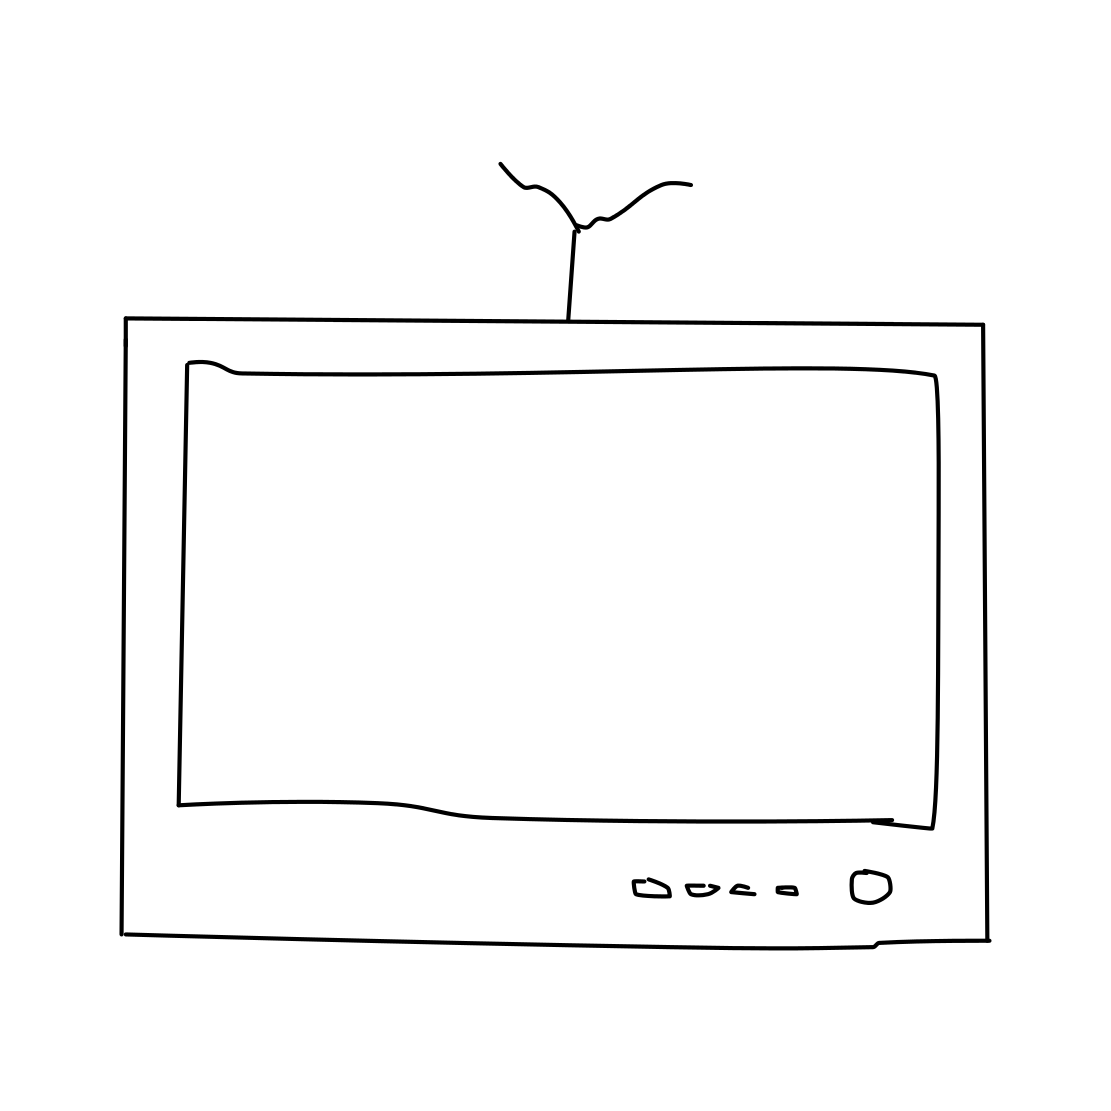Is there a sketchy tv in the picture? Indeed, the image shows a sketch-style illustration of a television. The TV has a simple design, featuring what appears to be an antenna on top, and some buttons and input slots at the bottom. Its screen occupies most of the front, but it's not showing any content — it's just an unlit blank space. 